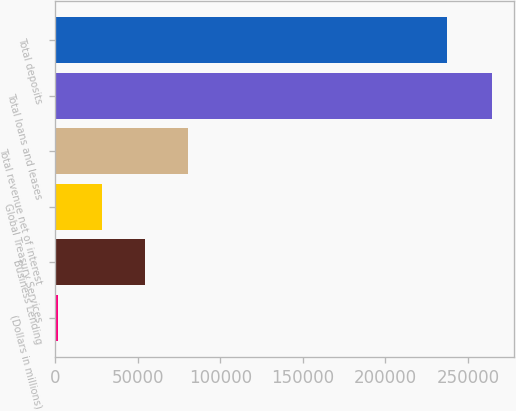Convert chart to OTSL. <chart><loc_0><loc_0><loc_500><loc_500><bar_chart><fcel>(Dollars in millions)<fcel>Business Lending<fcel>Global Treasury Services<fcel>Total revenue net of interest<fcel>Total loans and leases<fcel>Total deposits<nl><fcel>2011<fcel>54505.2<fcel>28258.1<fcel>80752.3<fcel>264482<fcel>237262<nl></chart> 